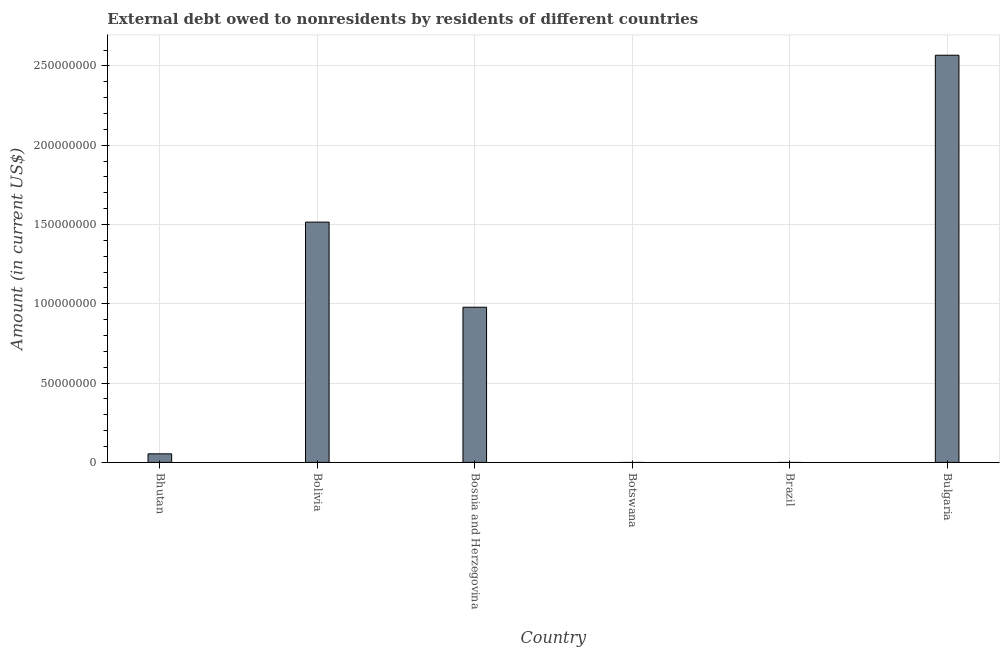Does the graph contain grids?
Your answer should be very brief. Yes. What is the title of the graph?
Your answer should be compact. External debt owed to nonresidents by residents of different countries. What is the debt in Bosnia and Herzegovina?
Offer a very short reply. 9.78e+07. Across all countries, what is the maximum debt?
Provide a short and direct response. 2.57e+08. Across all countries, what is the minimum debt?
Provide a succinct answer. 0. In which country was the debt maximum?
Provide a succinct answer. Bulgaria. What is the sum of the debt?
Offer a terse response. 5.11e+08. What is the difference between the debt in Bolivia and Bosnia and Herzegovina?
Your answer should be very brief. 5.37e+07. What is the average debt per country?
Your answer should be very brief. 8.52e+07. What is the median debt?
Give a very brief answer. 5.16e+07. What is the ratio of the debt in Bolivia to that in Bulgaria?
Your response must be concise. 0.59. Is the difference between the debt in Bhutan and Bosnia and Herzegovina greater than the difference between any two countries?
Ensure brevity in your answer.  No. What is the difference between the highest and the second highest debt?
Offer a very short reply. 1.05e+08. Is the sum of the debt in Bhutan and Bolivia greater than the maximum debt across all countries?
Provide a short and direct response. No. What is the difference between the highest and the lowest debt?
Offer a very short reply. 2.57e+08. In how many countries, is the debt greater than the average debt taken over all countries?
Give a very brief answer. 3. How many bars are there?
Make the answer very short. 4. How many countries are there in the graph?
Give a very brief answer. 6. Are the values on the major ticks of Y-axis written in scientific E-notation?
Offer a very short reply. No. What is the Amount (in current US$) in Bhutan?
Give a very brief answer. 5.40e+06. What is the Amount (in current US$) in Bolivia?
Make the answer very short. 1.51e+08. What is the Amount (in current US$) in Bosnia and Herzegovina?
Keep it short and to the point. 9.78e+07. What is the Amount (in current US$) in Bulgaria?
Keep it short and to the point. 2.57e+08. What is the difference between the Amount (in current US$) in Bhutan and Bolivia?
Offer a terse response. -1.46e+08. What is the difference between the Amount (in current US$) in Bhutan and Bosnia and Herzegovina?
Keep it short and to the point. -9.24e+07. What is the difference between the Amount (in current US$) in Bhutan and Bulgaria?
Ensure brevity in your answer.  -2.51e+08. What is the difference between the Amount (in current US$) in Bolivia and Bosnia and Herzegovina?
Make the answer very short. 5.37e+07. What is the difference between the Amount (in current US$) in Bolivia and Bulgaria?
Provide a succinct answer. -1.05e+08. What is the difference between the Amount (in current US$) in Bosnia and Herzegovina and Bulgaria?
Make the answer very short. -1.59e+08. What is the ratio of the Amount (in current US$) in Bhutan to that in Bolivia?
Offer a terse response. 0.04. What is the ratio of the Amount (in current US$) in Bhutan to that in Bosnia and Herzegovina?
Your response must be concise. 0.06. What is the ratio of the Amount (in current US$) in Bhutan to that in Bulgaria?
Your answer should be compact. 0.02. What is the ratio of the Amount (in current US$) in Bolivia to that in Bosnia and Herzegovina?
Ensure brevity in your answer.  1.55. What is the ratio of the Amount (in current US$) in Bolivia to that in Bulgaria?
Provide a succinct answer. 0.59. What is the ratio of the Amount (in current US$) in Bosnia and Herzegovina to that in Bulgaria?
Provide a short and direct response. 0.38. 